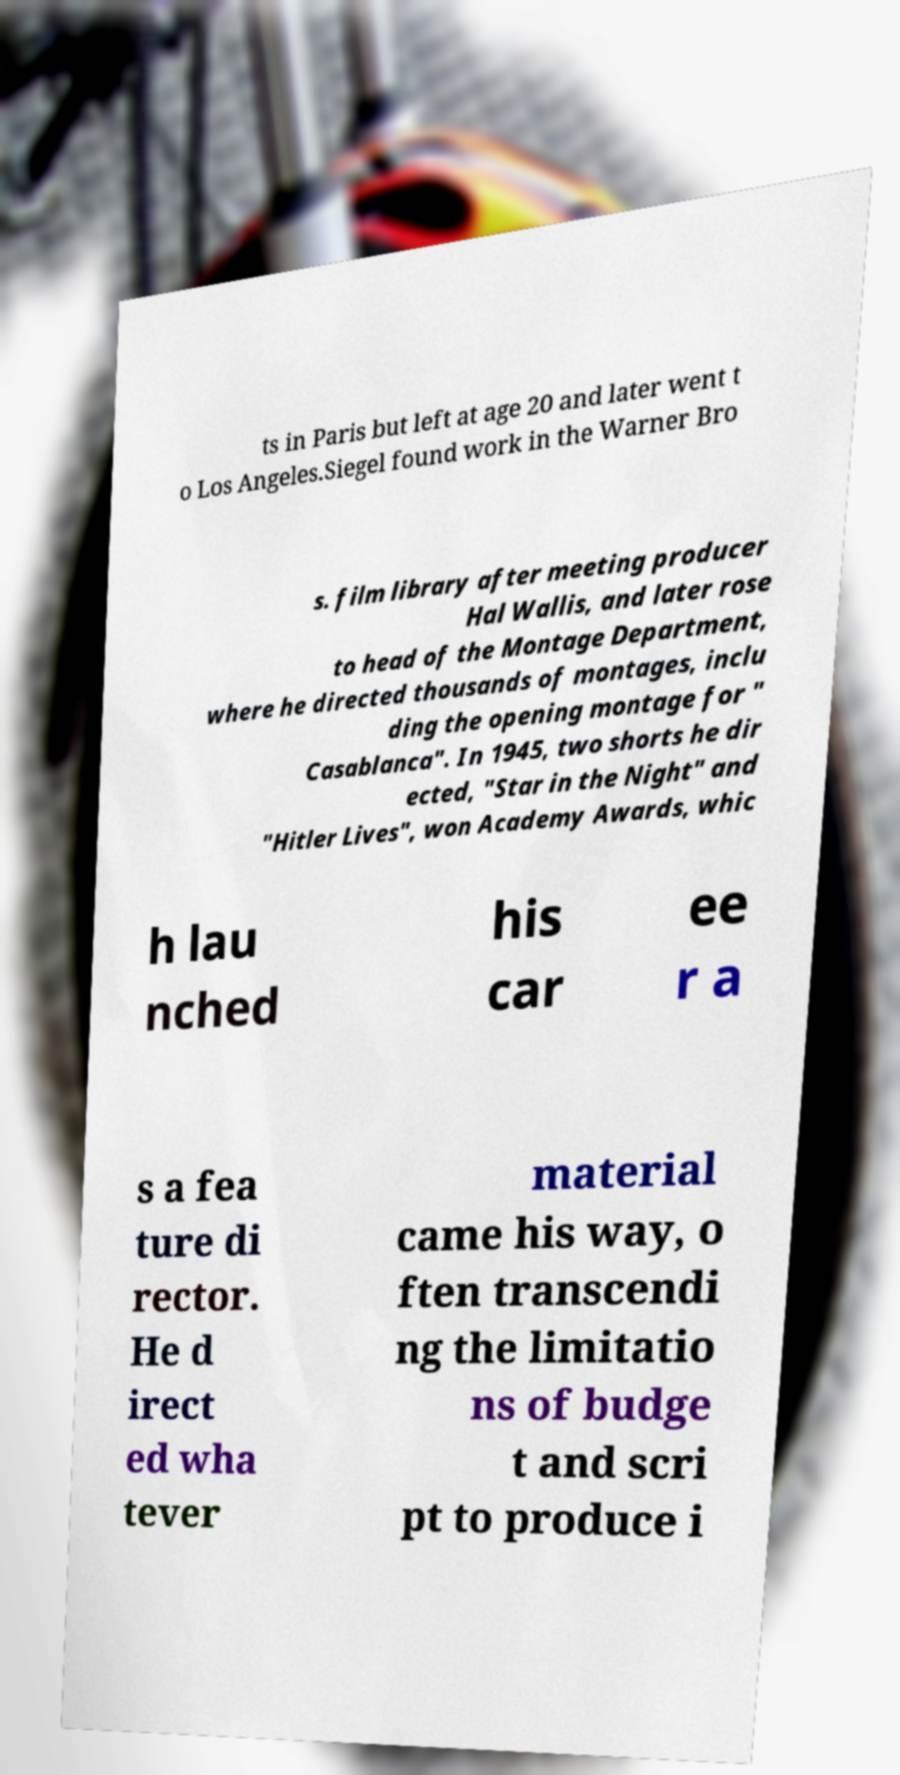What messages or text are displayed in this image? I need them in a readable, typed format. ts in Paris but left at age 20 and later went t o Los Angeles.Siegel found work in the Warner Bro s. film library after meeting producer Hal Wallis, and later rose to head of the Montage Department, where he directed thousands of montages, inclu ding the opening montage for " Casablanca". In 1945, two shorts he dir ected, "Star in the Night" and "Hitler Lives", won Academy Awards, whic h lau nched his car ee r a s a fea ture di rector. He d irect ed wha tever material came his way, o ften transcendi ng the limitatio ns of budge t and scri pt to produce i 